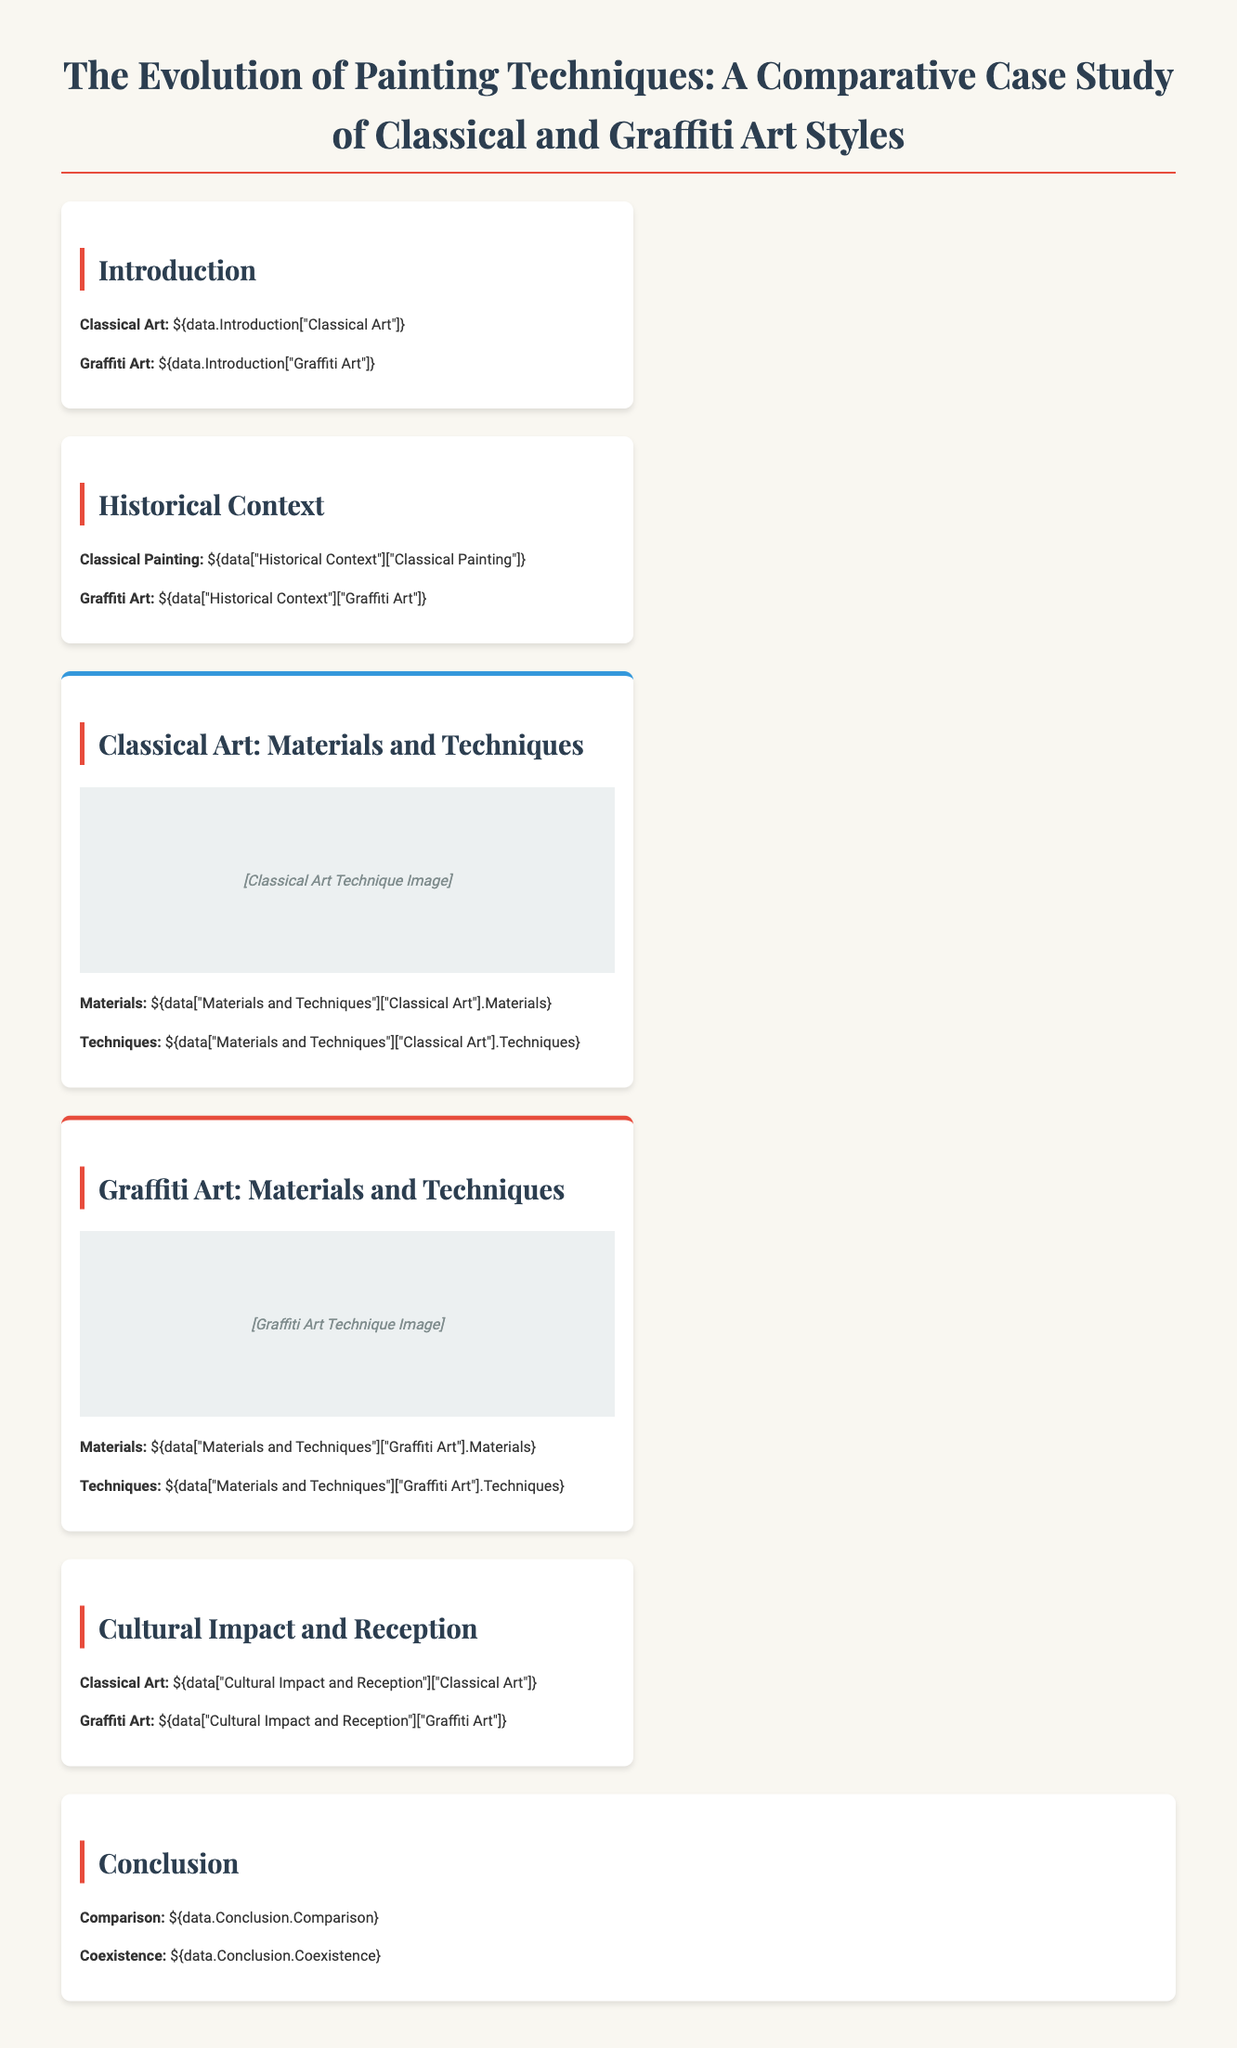What is the title of the case study? The title is prominently displayed at the top of the document, indicating the subject of the research.
Answer: The Evolution of Painting Techniques: A Comparative Case Study of Classical and Graffiti Art Styles What materials are used in Classical Art? This information is presented under the "Classical Art: Materials and Techniques" section, specifically detailing the materials utilized in classical painting.
Answer: [Classical Art Materials] What techniques are associated with Graffiti Art? The section on "Graffiti Art: Materials and Techniques" provides an overview of the techniques unique to graffiti.
Answer: [Graffiti Art Techniques] Which art style has a focus on historical context? The "Historical Context" section compares both art forms, allowing for an understanding of their backgrounds.
Answer: Both What does the conclusion emphasize about the comparison? The conclusion summarizes findings, highlighting key differences and similarities drawn from the analysis.
Answer: [Conclusion Comparison] How are the materials used in Classical and Graffiti Art contrasted? The document outlines the different materials in their respective sections, showcasing their uniqueness.
Answer: [Materials Comparison] What cultural impact is discussed regarding Graffiti Art? The "Cultural Impact and Reception" section elaborates on how graffiti has influenced society and its perception.
Answer: [Graffiti Art Impact] 